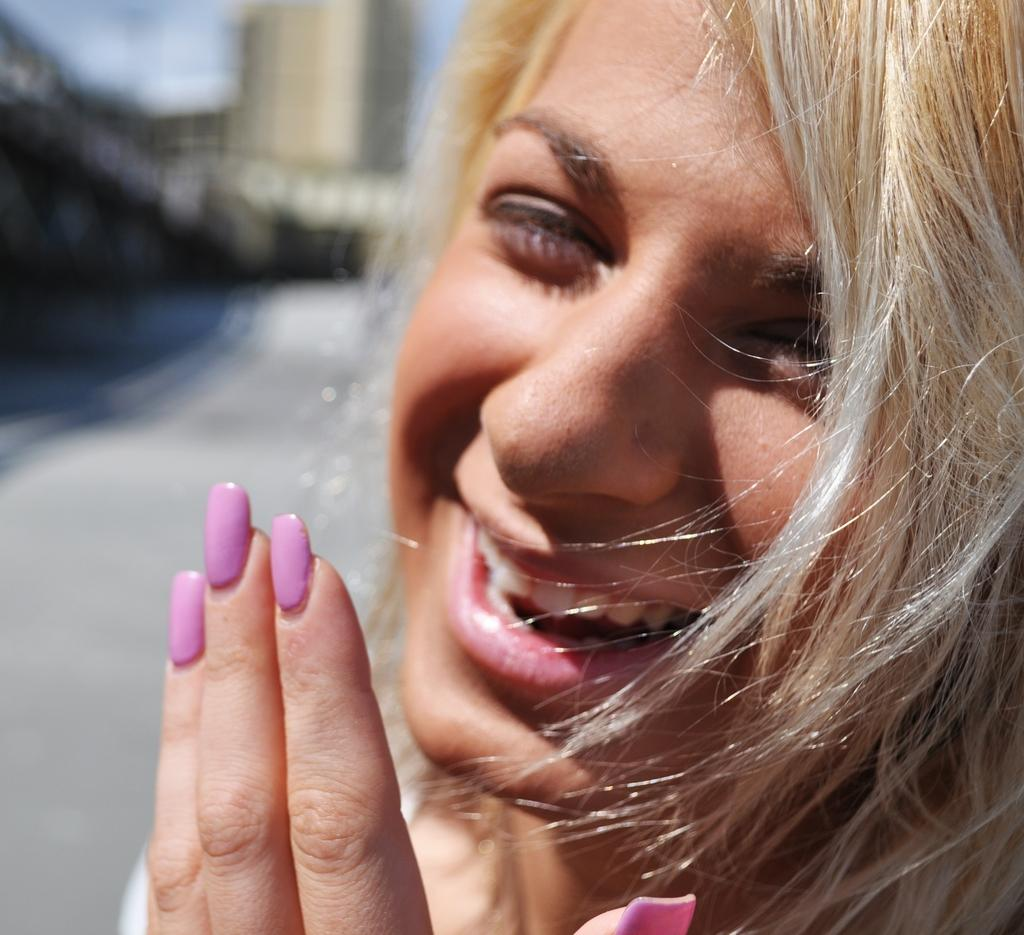Who is present in the image? There is a woman in the image. What is the woman doing in the image? The woman is smiling in the image. Can you describe the background of the image? The background of the image is blurred. What type of cannon is being fired in the background of the image? There is no cannon present in the image; the background is blurred. How much debt is the woman in the image responsible for? There is no information about the woman's debt in the image. What type of stew is being prepared in the image? There is no stew or cooking activity present in the image. 